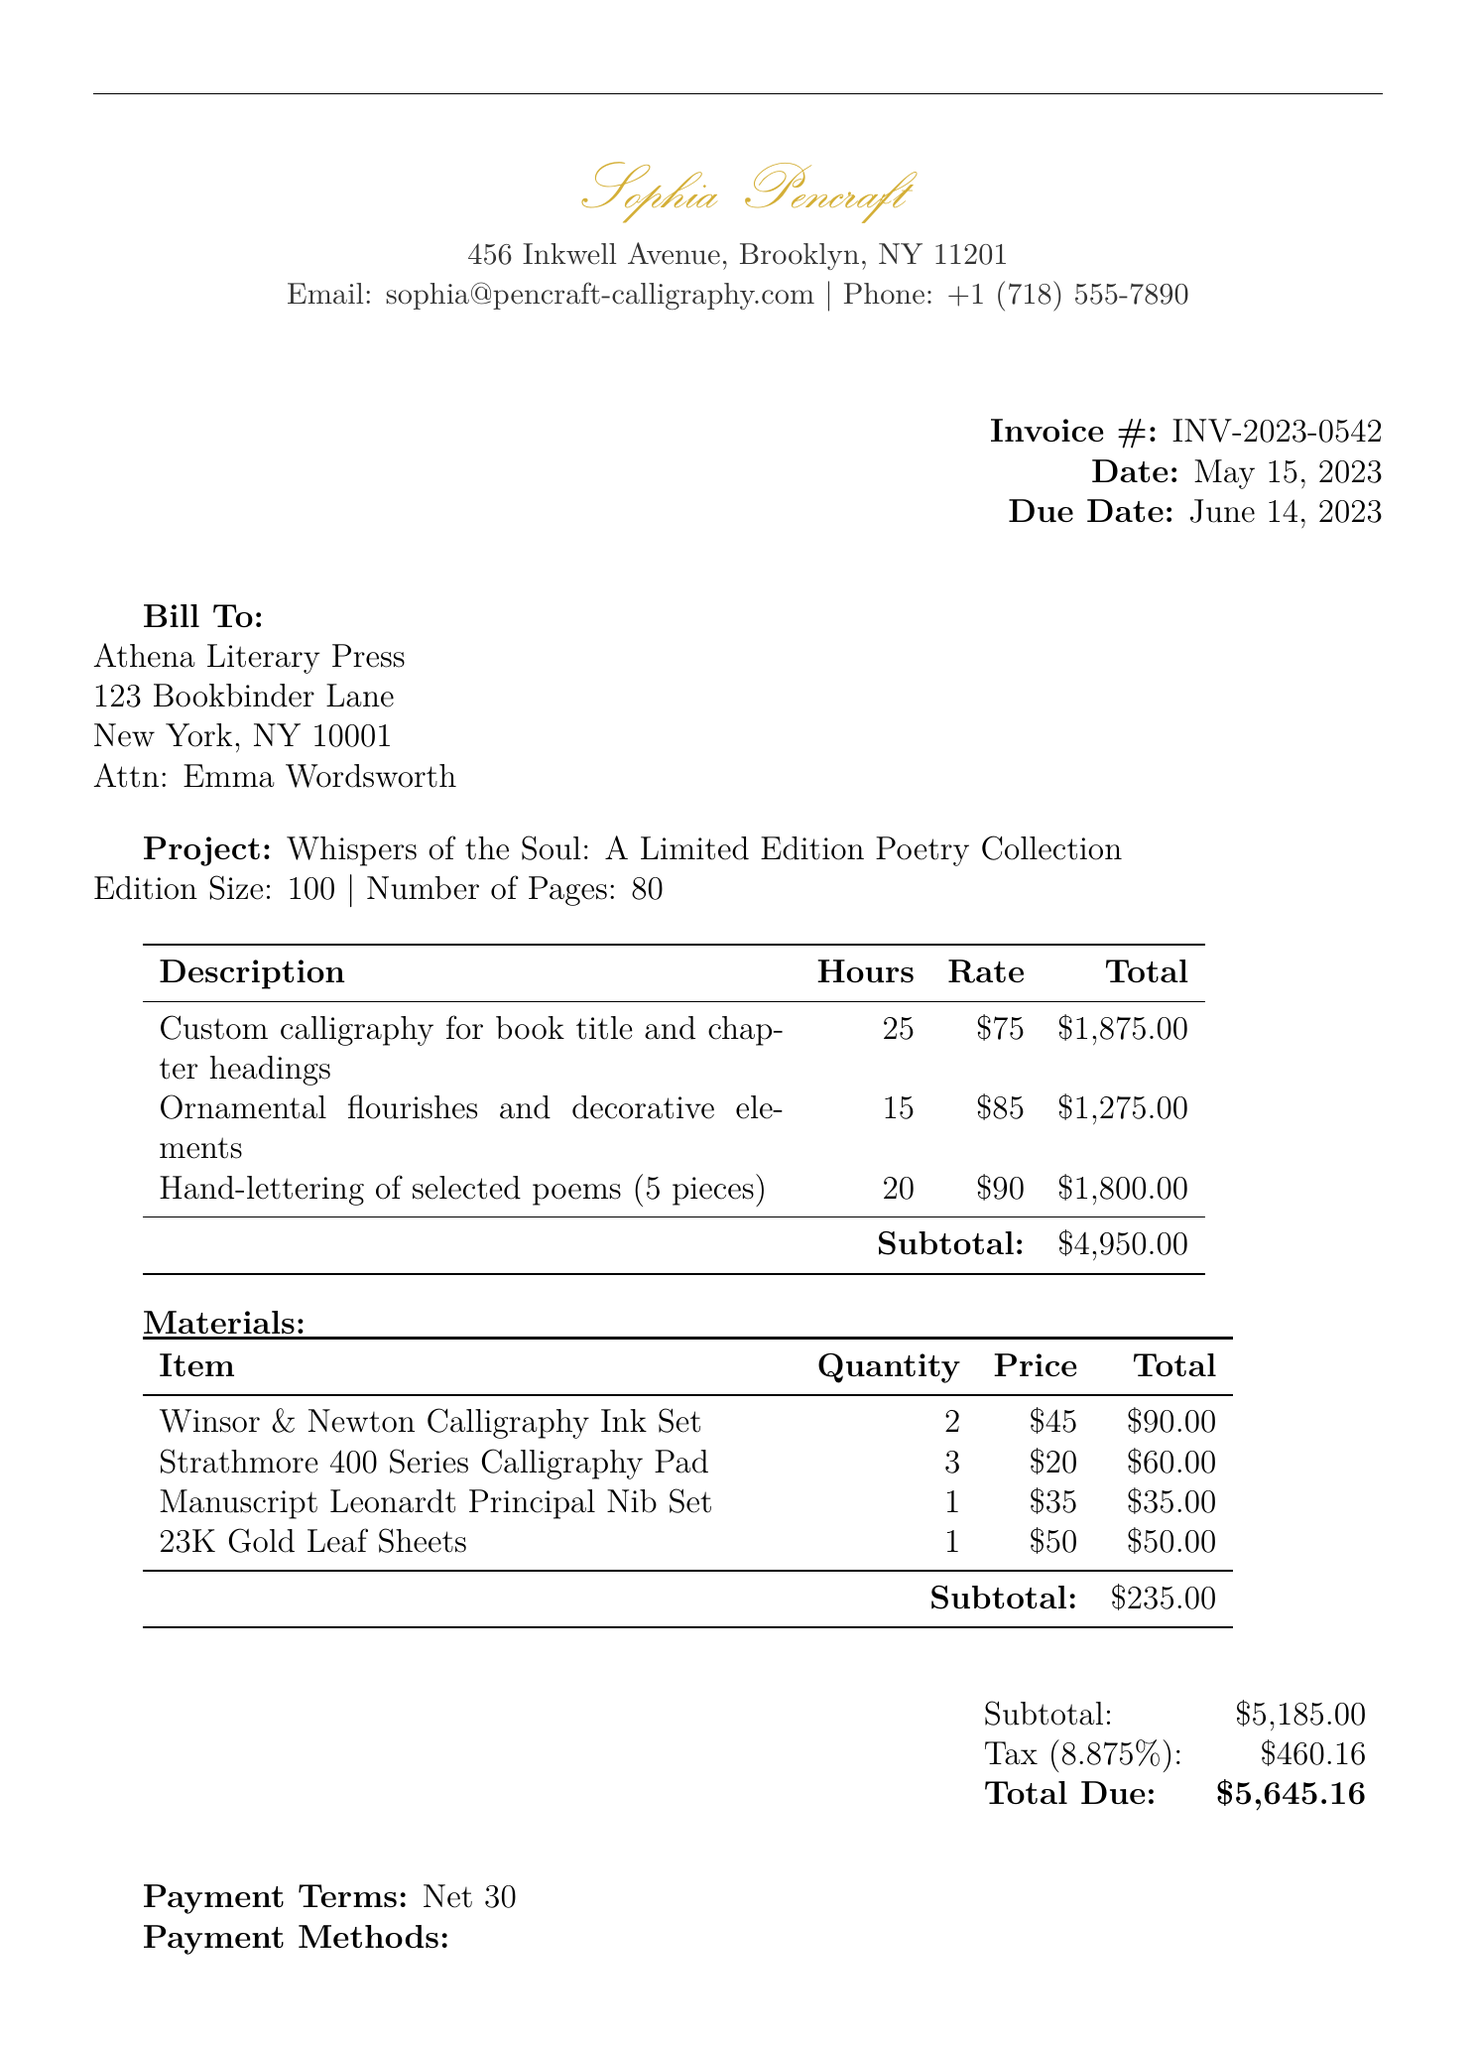What is the invoice number? The invoice number is a unique identifier for the document, which is listed as INV-2023-0542.
Answer: INV-2023-0542 What is the total due amount? The total due amount is the final amount that needs to be paid, which is specified as $5645.16.
Answer: $5645.16 Who is the contact person for the client? The contact person for the client is mentioned as Emma Wordsworth, who is associated with Athena Literary Press.
Answer: Emma Wordsworth How many hours were billed for the ornamental flourishes? The document states that 15 hours were billed for the ornamental flourishes and decorative elements service.
Answer: 15 What is the tax rate applied to the services? The document specifies the tax rate applied, which is 8.875%.
Answer: 8.875% What is the total hours worked by the calligrapher? The total hours worked can be calculated by adding up the hours for each service: 25 + 15 + 20 = 60 hours.
Answer: 60 What is the quantity of the Winsor & Newton Calligraphy Ink Set? The document indicates that the quantity of the Winsor & Newton Calligraphy Ink Set is 2.
Answer: 2 What is the payment term specified in the invoice? The invoice clearly states that the payment terms are Net 30, meaning payment is due within 30 days.
Answer: Net 30 What is the composition of the service provided for hand-lettering? The service provided for hand-lettering consists of selected poems with a specified count of 5 pieces.
Answer: 5 pieces 